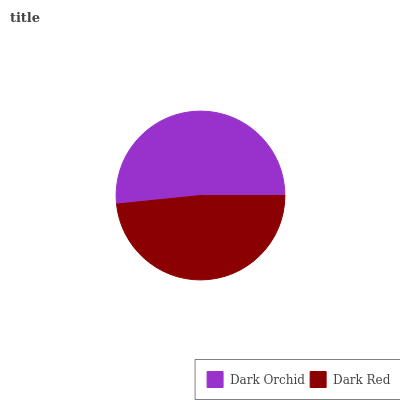Is Dark Red the minimum?
Answer yes or no. Yes. Is Dark Orchid the maximum?
Answer yes or no. Yes. Is Dark Red the maximum?
Answer yes or no. No. Is Dark Orchid greater than Dark Red?
Answer yes or no. Yes. Is Dark Red less than Dark Orchid?
Answer yes or no. Yes. Is Dark Red greater than Dark Orchid?
Answer yes or no. No. Is Dark Orchid less than Dark Red?
Answer yes or no. No. Is Dark Orchid the high median?
Answer yes or no. Yes. Is Dark Red the low median?
Answer yes or no. Yes. Is Dark Red the high median?
Answer yes or no. No. Is Dark Orchid the low median?
Answer yes or no. No. 